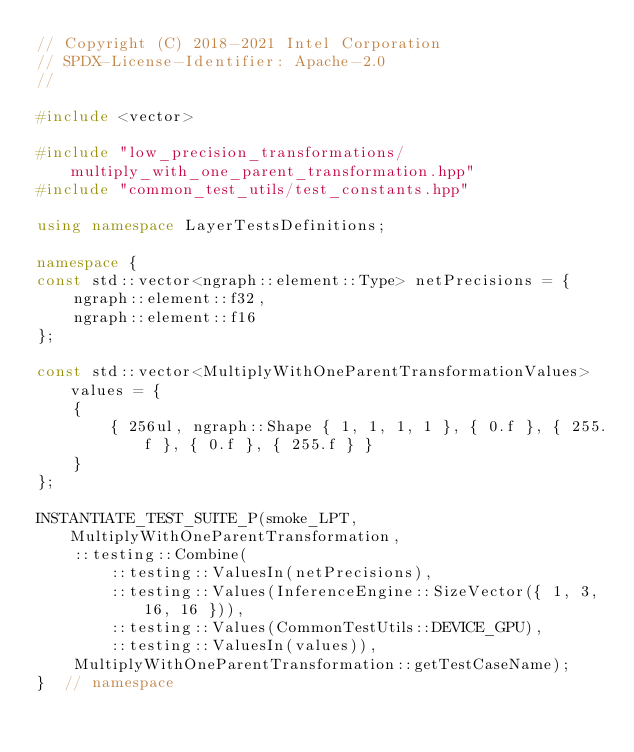<code> <loc_0><loc_0><loc_500><loc_500><_C++_>// Copyright (C) 2018-2021 Intel Corporation
// SPDX-License-Identifier: Apache-2.0
//

#include <vector>

#include "low_precision_transformations/multiply_with_one_parent_transformation.hpp"
#include "common_test_utils/test_constants.hpp"

using namespace LayerTestsDefinitions;

namespace {
const std::vector<ngraph::element::Type> netPrecisions = {
    ngraph::element::f32,
    ngraph::element::f16
};

const std::vector<MultiplyWithOneParentTransformationValues> values = {
    {
        { 256ul, ngraph::Shape { 1, 1, 1, 1 }, { 0.f }, { 255.f }, { 0.f }, { 255.f } }
    }
};

INSTANTIATE_TEST_SUITE_P(smoke_LPT, MultiplyWithOneParentTransformation,
    ::testing::Combine(
        ::testing::ValuesIn(netPrecisions),
        ::testing::Values(InferenceEngine::SizeVector({ 1, 3, 16, 16 })),
        ::testing::Values(CommonTestUtils::DEVICE_GPU),
        ::testing::ValuesIn(values)),
    MultiplyWithOneParentTransformation::getTestCaseName);
}  // namespace
</code> 